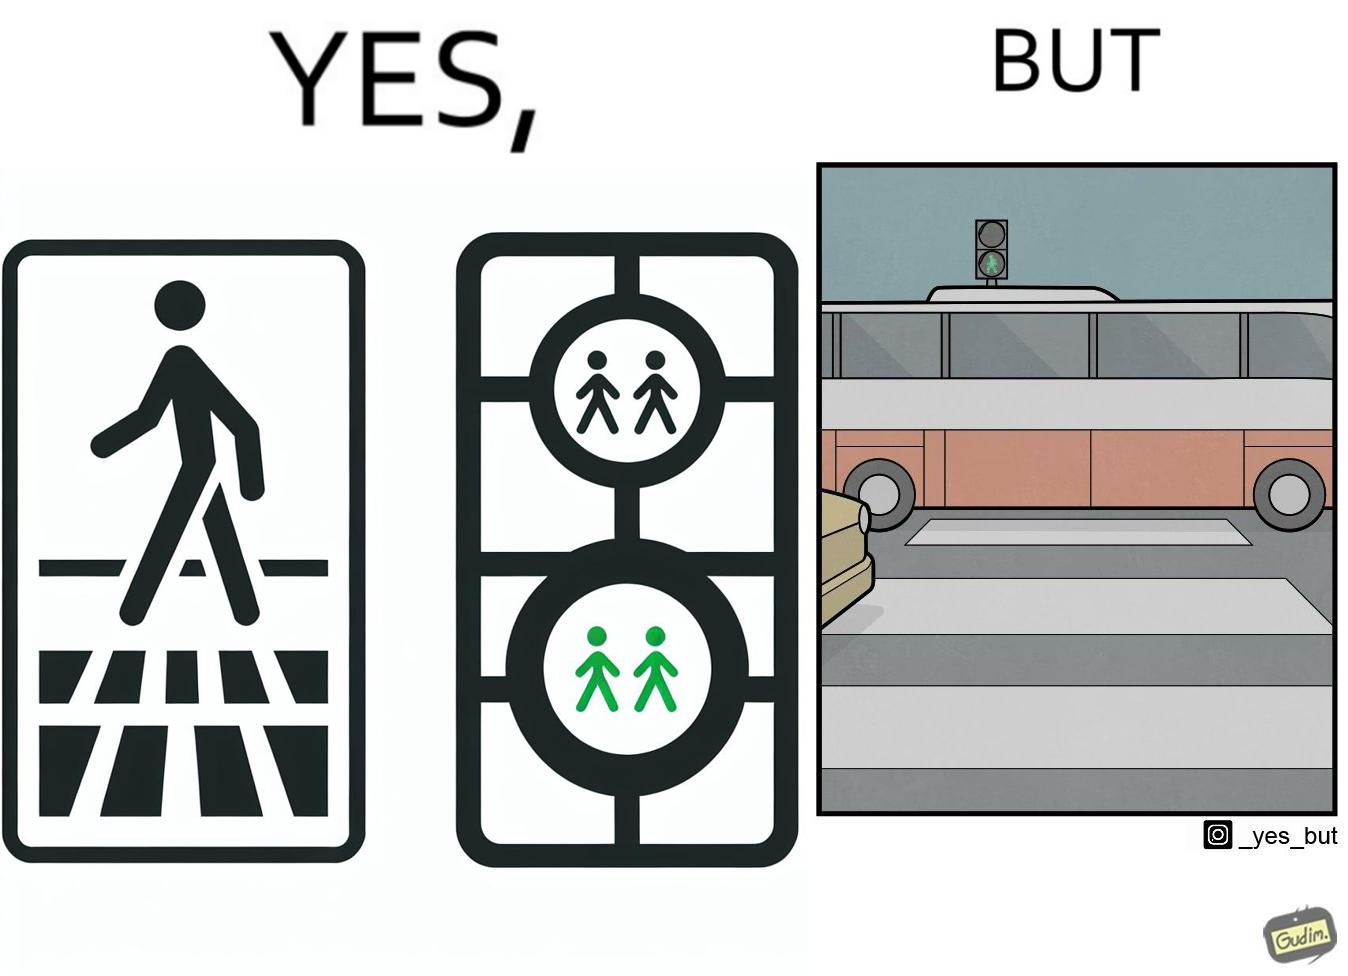Explain the humor or irony in this image. The image is ironic, because even when the signal is green for the pedestrians but they can't cross the road because of the vehicles standing on the zebra crossing 